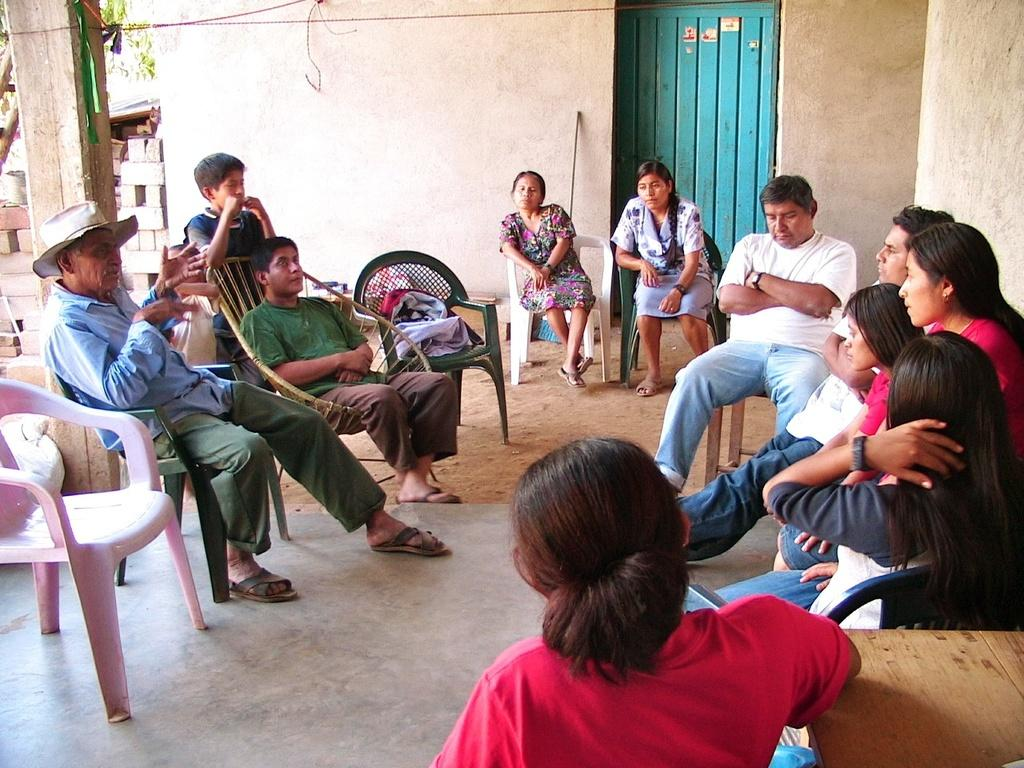How many people are in the image? There is a group of people in the image. What are the people doing in the image? The people are sitting on chairs. What can be seen on the chairs besides the people? There is at least one bag on the chairs. What architectural features can be seen in the background of the image? There is a wall, a door, and a pillar in the background of the image. What natural elements can be seen in the background of the image? There is a tree in the background of the image. What man-made objects can be seen in the background of the image? There are wires in the background of the image. How many cushions are visible on the chairs in the image? There is no mention of cushions on the chairs in the image. 